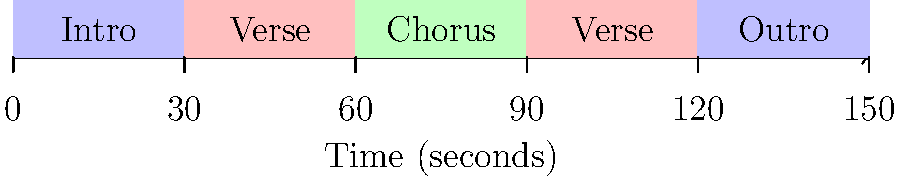As an independent artist inspired by Anesha & Antea Birchett, you're analyzing song structures. The timeline diagram above represents the structure of a song. What is the total duration of the verses in this song structure? To determine the total duration of the verses in this song structure, let's follow these steps:

1. Identify the verse sections in the diagram:
   - There are two verse sections, both colored in pale red.

2. Determine the duration of each verse:
   - The timeline is marked in 30-second intervals.
   - Each verse spans two of these intervals.
   - Therefore, each verse is 60 seconds long.

3. Calculate the total duration of verses:
   - There are two verses, each 60 seconds long.
   - Total duration = 2 * 60 seconds = 120 seconds

This analysis shows how understanding song structure can help in crafting well-balanced compositions, a skill valued by successful songwriters like the Birchett sisters.
Answer: 120 seconds 